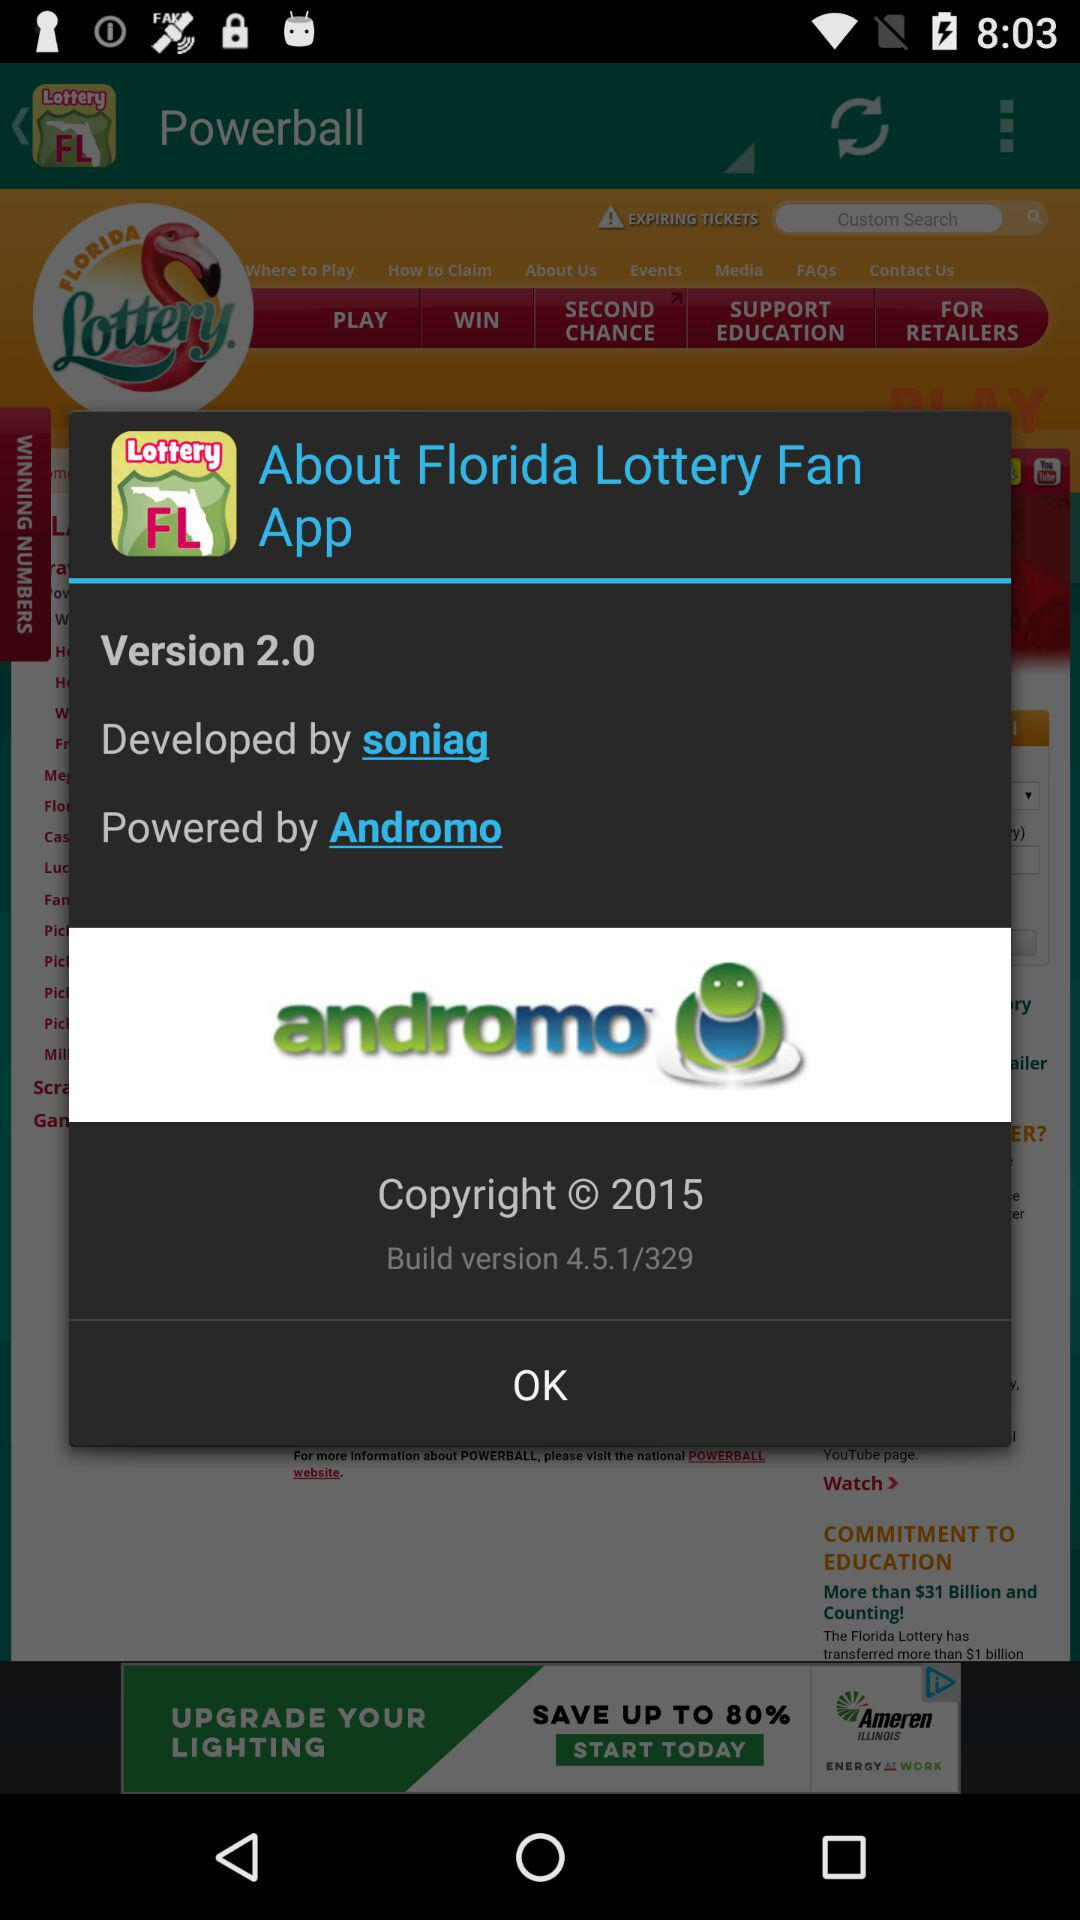What is the version? The version is 2.0. 